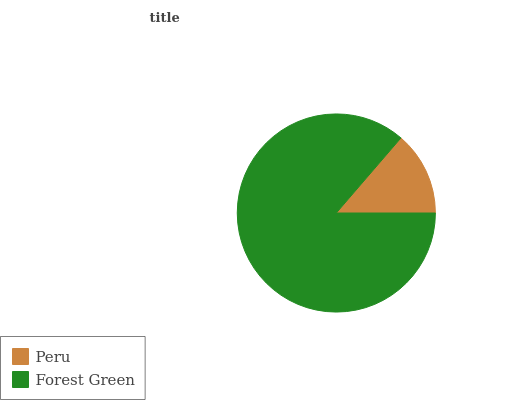Is Peru the minimum?
Answer yes or no. Yes. Is Forest Green the maximum?
Answer yes or no. Yes. Is Forest Green the minimum?
Answer yes or no. No. Is Forest Green greater than Peru?
Answer yes or no. Yes. Is Peru less than Forest Green?
Answer yes or no. Yes. Is Peru greater than Forest Green?
Answer yes or no. No. Is Forest Green less than Peru?
Answer yes or no. No. Is Forest Green the high median?
Answer yes or no. Yes. Is Peru the low median?
Answer yes or no. Yes. Is Peru the high median?
Answer yes or no. No. Is Forest Green the low median?
Answer yes or no. No. 